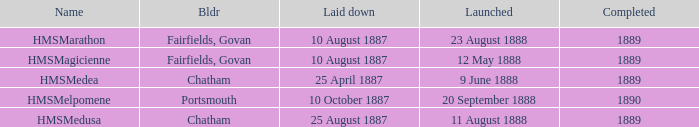Which builder completed after 1889? Portsmouth. 